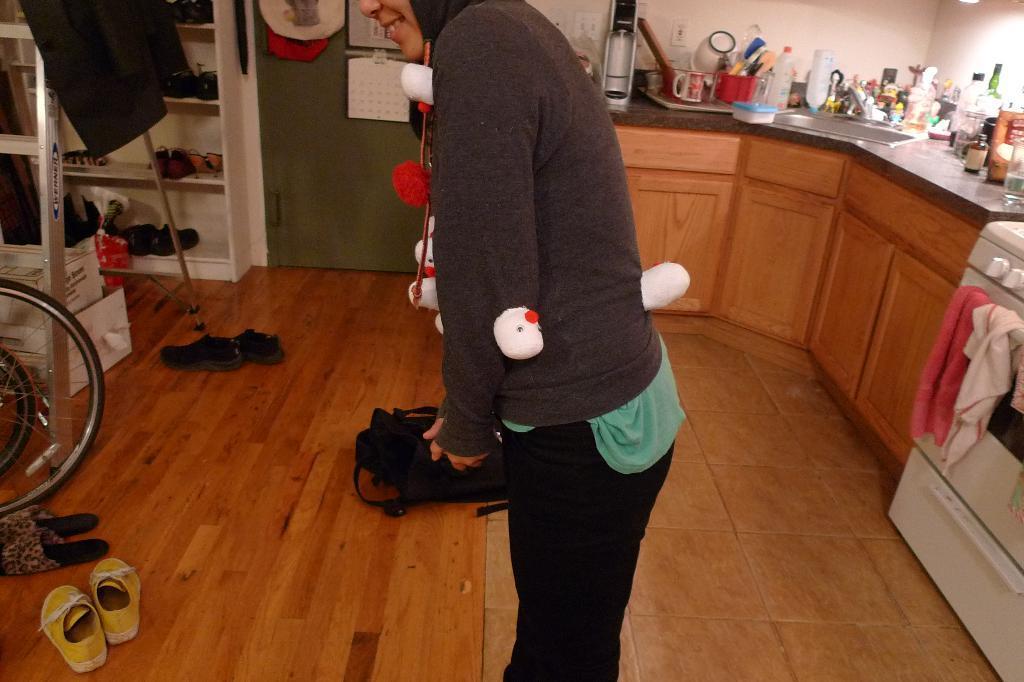Please provide a concise description of this image. In the center of the image we can see one person is standing and she is wearing a jacket and she is smiling. On the jacket, we can see some white and red color objects. In the background there is a wall, door, ladder, one backpack, jacket, calendar, table, washing machine, kitchen cloths, boxes, footwear's, racks, cupboards, wheels and a few other objects. On the table, we can see bottles, glasses, containers, cups, boxes, one sink and a few other objects. 